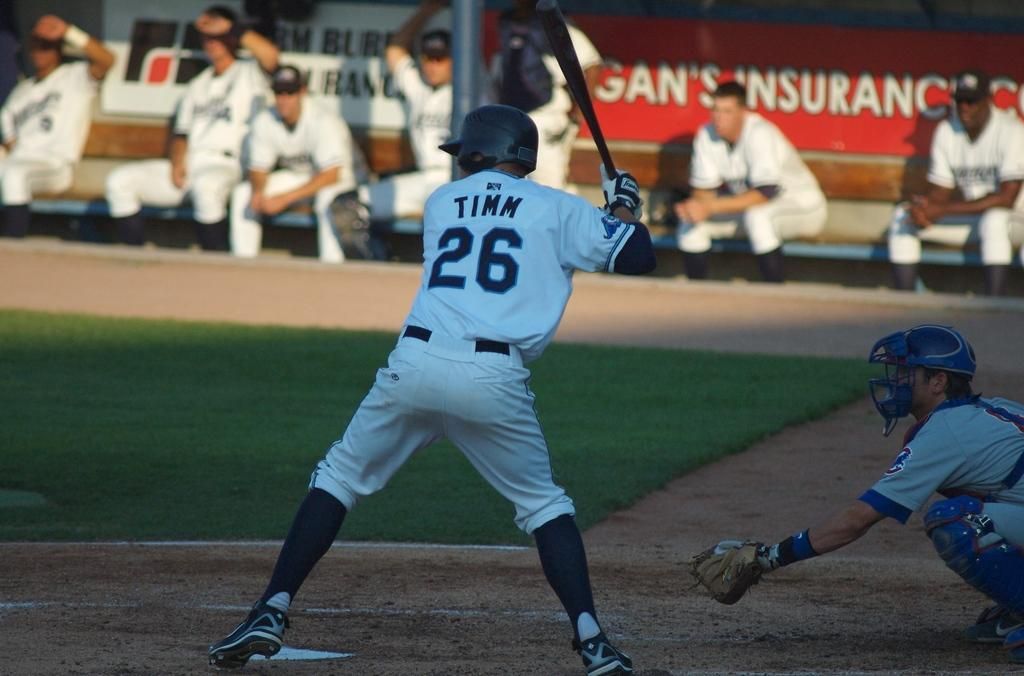<image>
Create a compact narrative representing the image presented. a player that has the number 26 on their back 